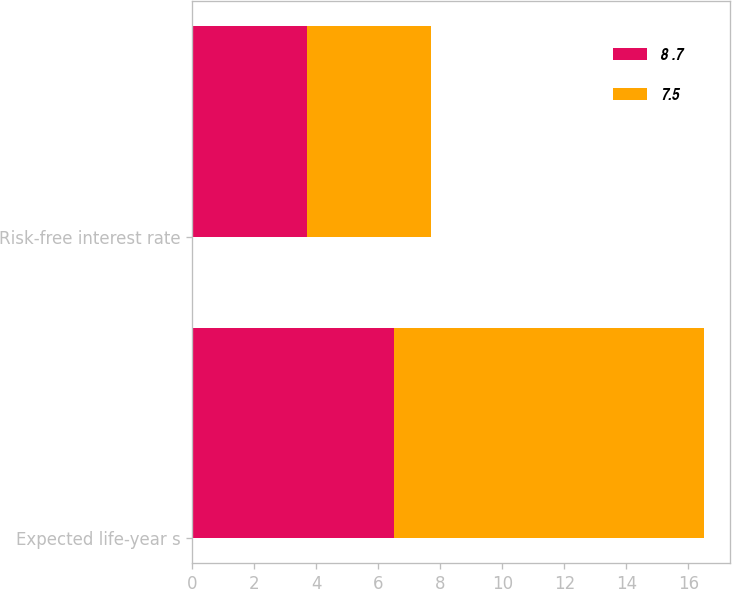<chart> <loc_0><loc_0><loc_500><loc_500><stacked_bar_chart><ecel><fcel>Expected life-year s<fcel>Risk-free interest rate<nl><fcel>8 .7<fcel>6.5<fcel>3.71<nl><fcel>7.5<fcel>10<fcel>3.99<nl></chart> 